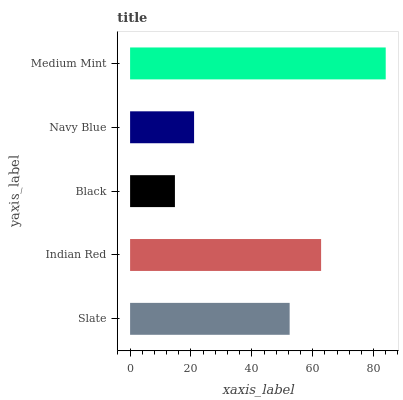Is Black the minimum?
Answer yes or no. Yes. Is Medium Mint the maximum?
Answer yes or no. Yes. Is Indian Red the minimum?
Answer yes or no. No. Is Indian Red the maximum?
Answer yes or no. No. Is Indian Red greater than Slate?
Answer yes or no. Yes. Is Slate less than Indian Red?
Answer yes or no. Yes. Is Slate greater than Indian Red?
Answer yes or no. No. Is Indian Red less than Slate?
Answer yes or no. No. Is Slate the high median?
Answer yes or no. Yes. Is Slate the low median?
Answer yes or no. Yes. Is Navy Blue the high median?
Answer yes or no. No. Is Indian Red the low median?
Answer yes or no. No. 